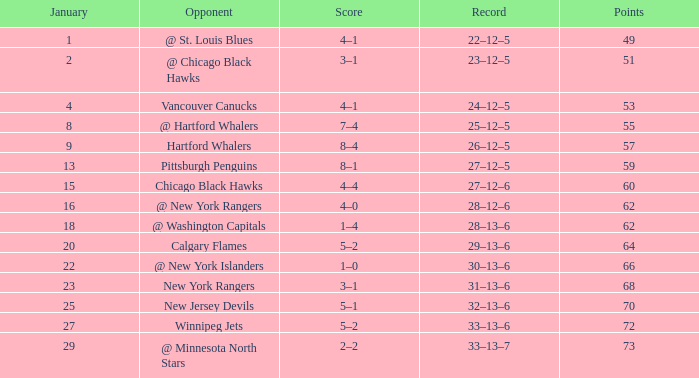In how many games is the score 1-0 and the total points are below 66? 0.0. 